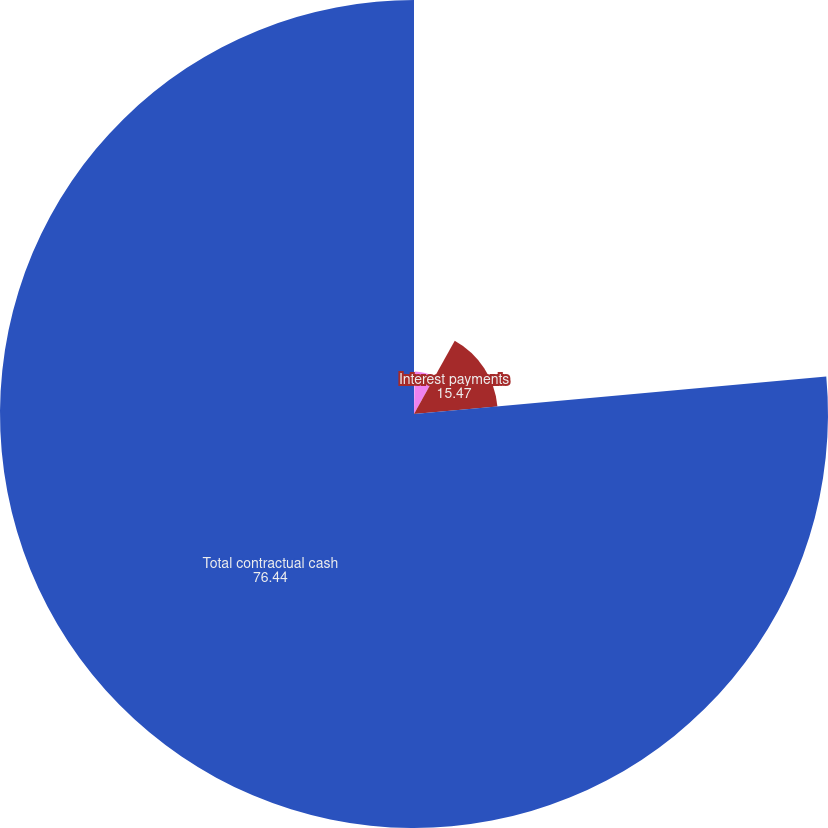<chart> <loc_0><loc_0><loc_500><loc_500><pie_chart><fcel>Long-term debt<fcel>Operating leases<fcel>Interest payments<fcel>Total contractual cash<nl><fcel>0.23%<fcel>7.85%<fcel>15.47%<fcel>76.44%<nl></chart> 